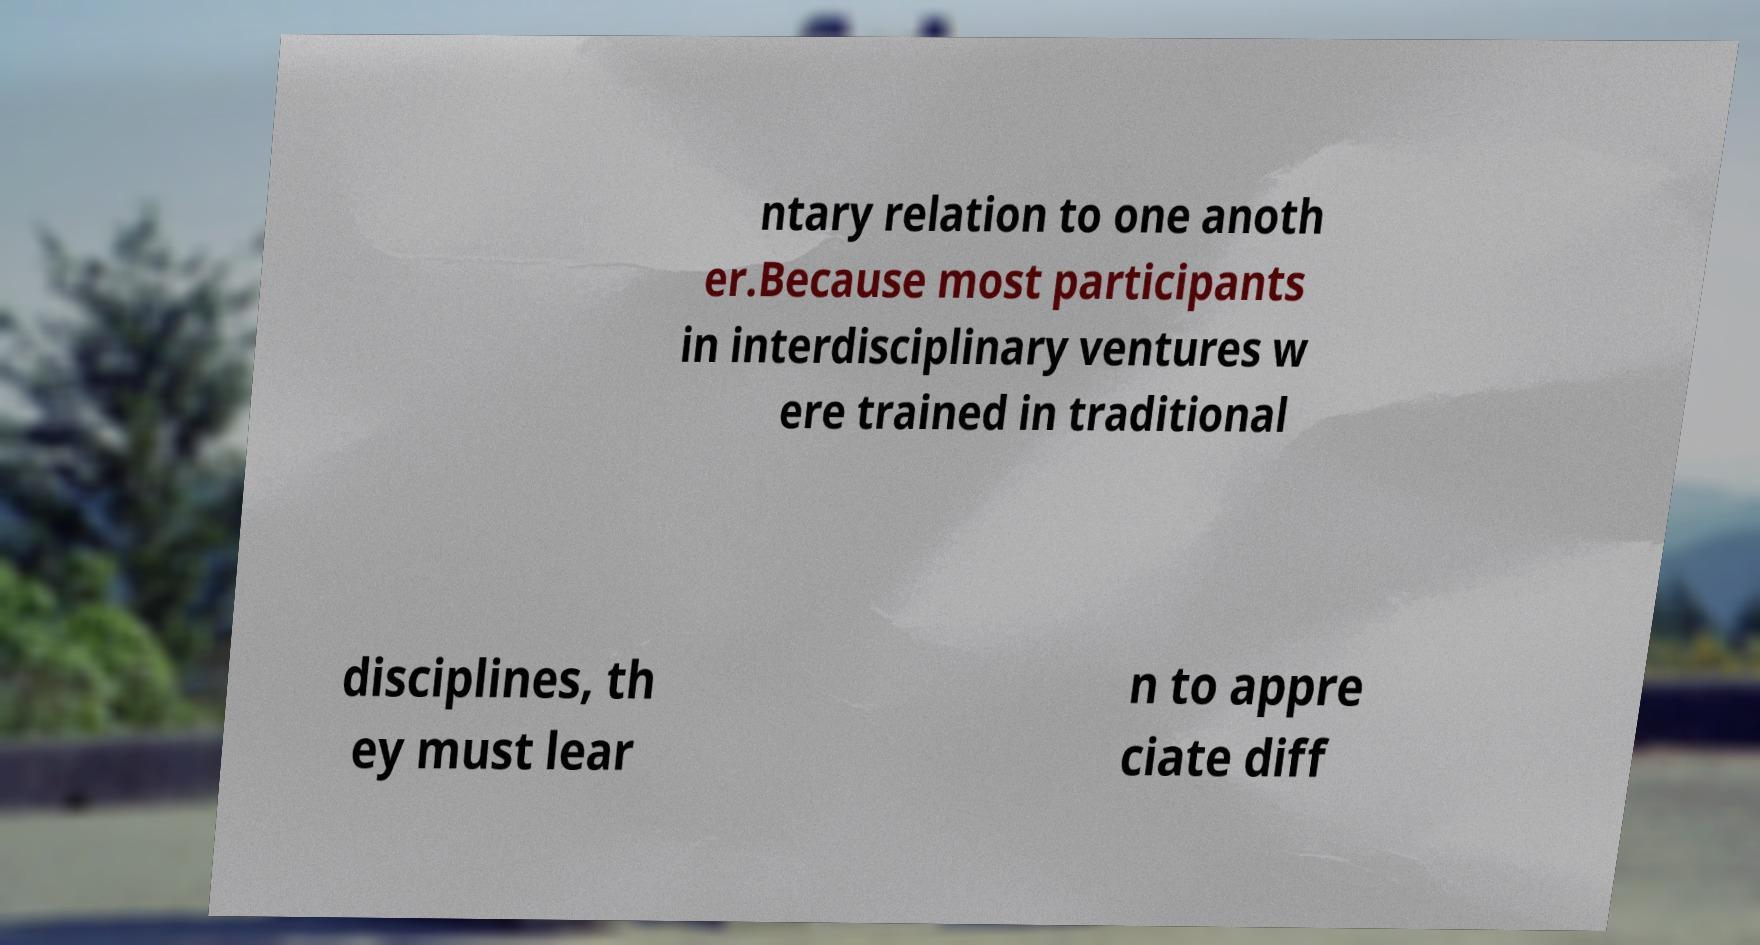Can you accurately transcribe the text from the provided image for me? ntary relation to one anoth er.Because most participants in interdisciplinary ventures w ere trained in traditional disciplines, th ey must lear n to appre ciate diff 